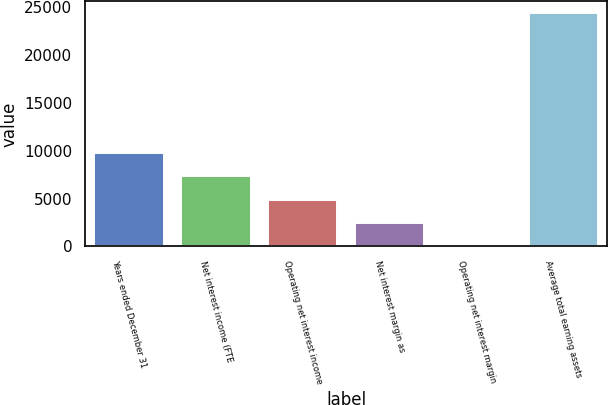Convert chart to OTSL. <chart><loc_0><loc_0><loc_500><loc_500><bar_chart><fcel>Years ended December 31<fcel>Net interest income (FTE<fcel>Operating net interest income<fcel>Net interest margin as<fcel>Operating net interest margin<fcel>Average total earning assets<nl><fcel>9748.7<fcel>7312.48<fcel>4876.26<fcel>2440.04<fcel>3.82<fcel>24366<nl></chart> 